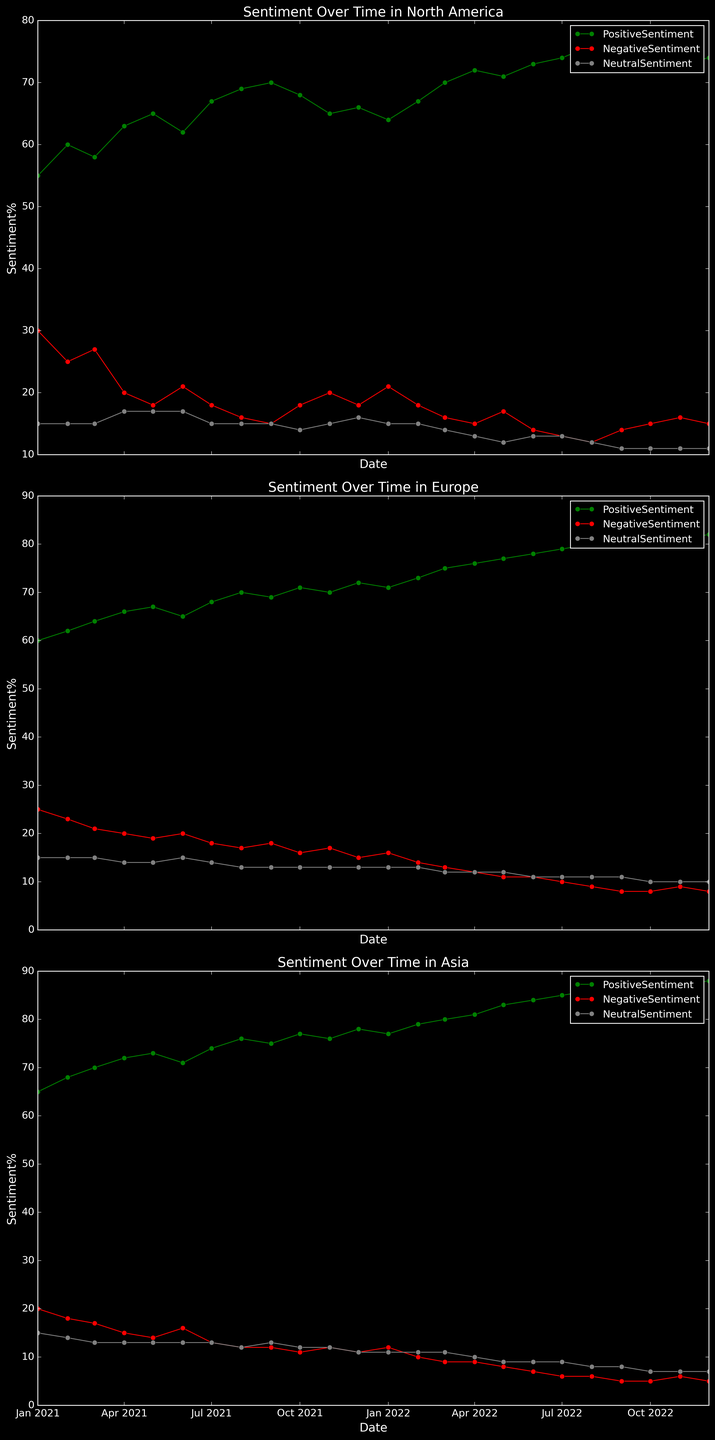What region showed the highest overall positive sentiment throughout the period? To determine which region showed the highest overall positive sentiment, compare the general trends of the positive sentiment lines across North America, Europe, and Asia. Asia's positive sentiment line consistently stays higher than those of North America and Europe, especially in the later months of 2022.
Answer: Asia Which region experienced the most significant increase in positive sentiment from the beginning to the end of the period? Observe the positive sentiment lines and measure the growth from January 2021 to December 2022 for each region. Asia starts at 65% and ends at 88%, an increase of 23%, which is the highest among the regions.
Answer: Asia How did negative sentiment in North America change from January 2021 to December 2022? Look at the negative sentiment line for North America from January 2021 to December 2022. It starts at 30% and decreases to 15%. The trend shows a decline in negative sentiment.
Answer: Declined What is the average positive sentiment in Europe over the period shown? Calculate the average of the positive sentiment values for Europe over the period. (60+62+64+66+67+65+68+70+69+71+70+72+71+73+75+76+77+78+79+80+81+82+81+82)/24 = 71.88%.
Answer: 71.88% Which month shows the highest negative sentiment in Asia? Identify the peak value of the negative sentiment line for Asia. It is at 20% in January 2021.
Answer: January 2021 Between North America and Europe, which region had a more stable neutral sentiment throughout the period? Compare the fluctuations in the neutral sentiment lines for North America and Europe. Neutral sentiment in both regions remains mostly constant, but Europe shows a slightly more stable line with smaller variations.
Answer: Europe What are the changes in positive sentiment in North America between January and July 2021? Track the positive sentiment line for North America from January to July 2021. It changes from 55% to 67%, an increase of 12%.
Answer: Increased by 12% How does the positive sentiment in Asia compare to North America in December 2022? Compare the positive sentiment values for Asia and North America in December 2022. Asia has 88%, while North America has 74%.
Answer: Asia is higher Which region saw the smallest fluctuation in negative sentiment over the whole period? Assess the negative sentiment lines for all regions and identify the smallest fluctuation. Europe's negative sentiment fluctuates between 25% and 8%, showing relatively smaller variations compared to other regions.
Answer: Europe 